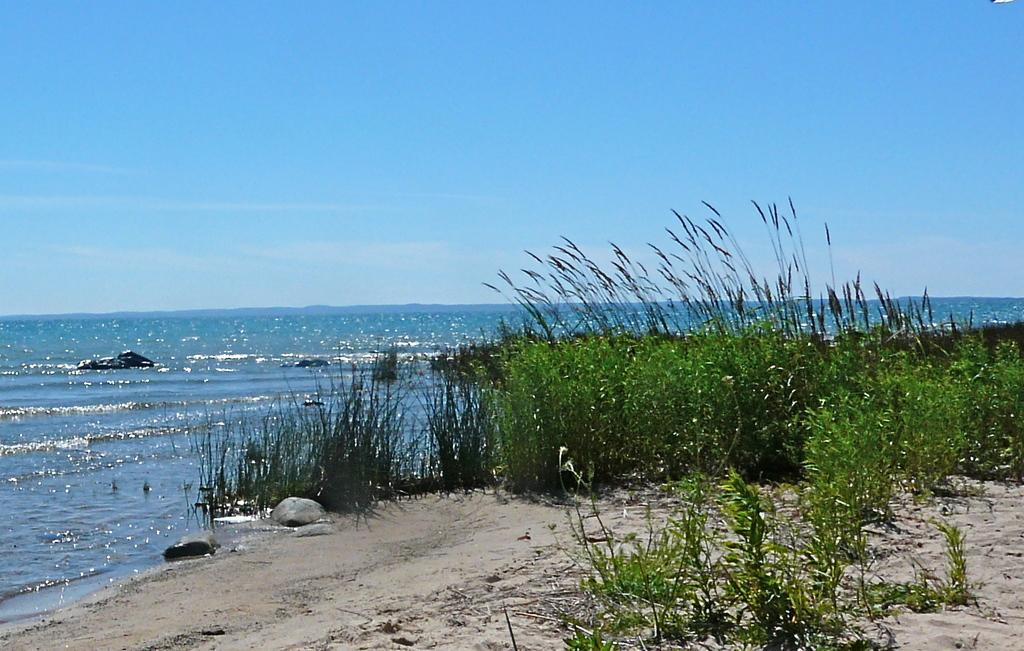What type of environment is depicted at the bottom of the image? There are plants and sand at the bottom of the image. What can be seen in the background of the image? There is a beach in the background of the image. What is visible at the top of the image? The sky is visible at the top of the image. What type of tomatoes are being taught in the school in the image? There is no school or tomatoes present in the image. How many students are in the school in the image? There is no school present in the image, so it is not possible to determine the number of students. 